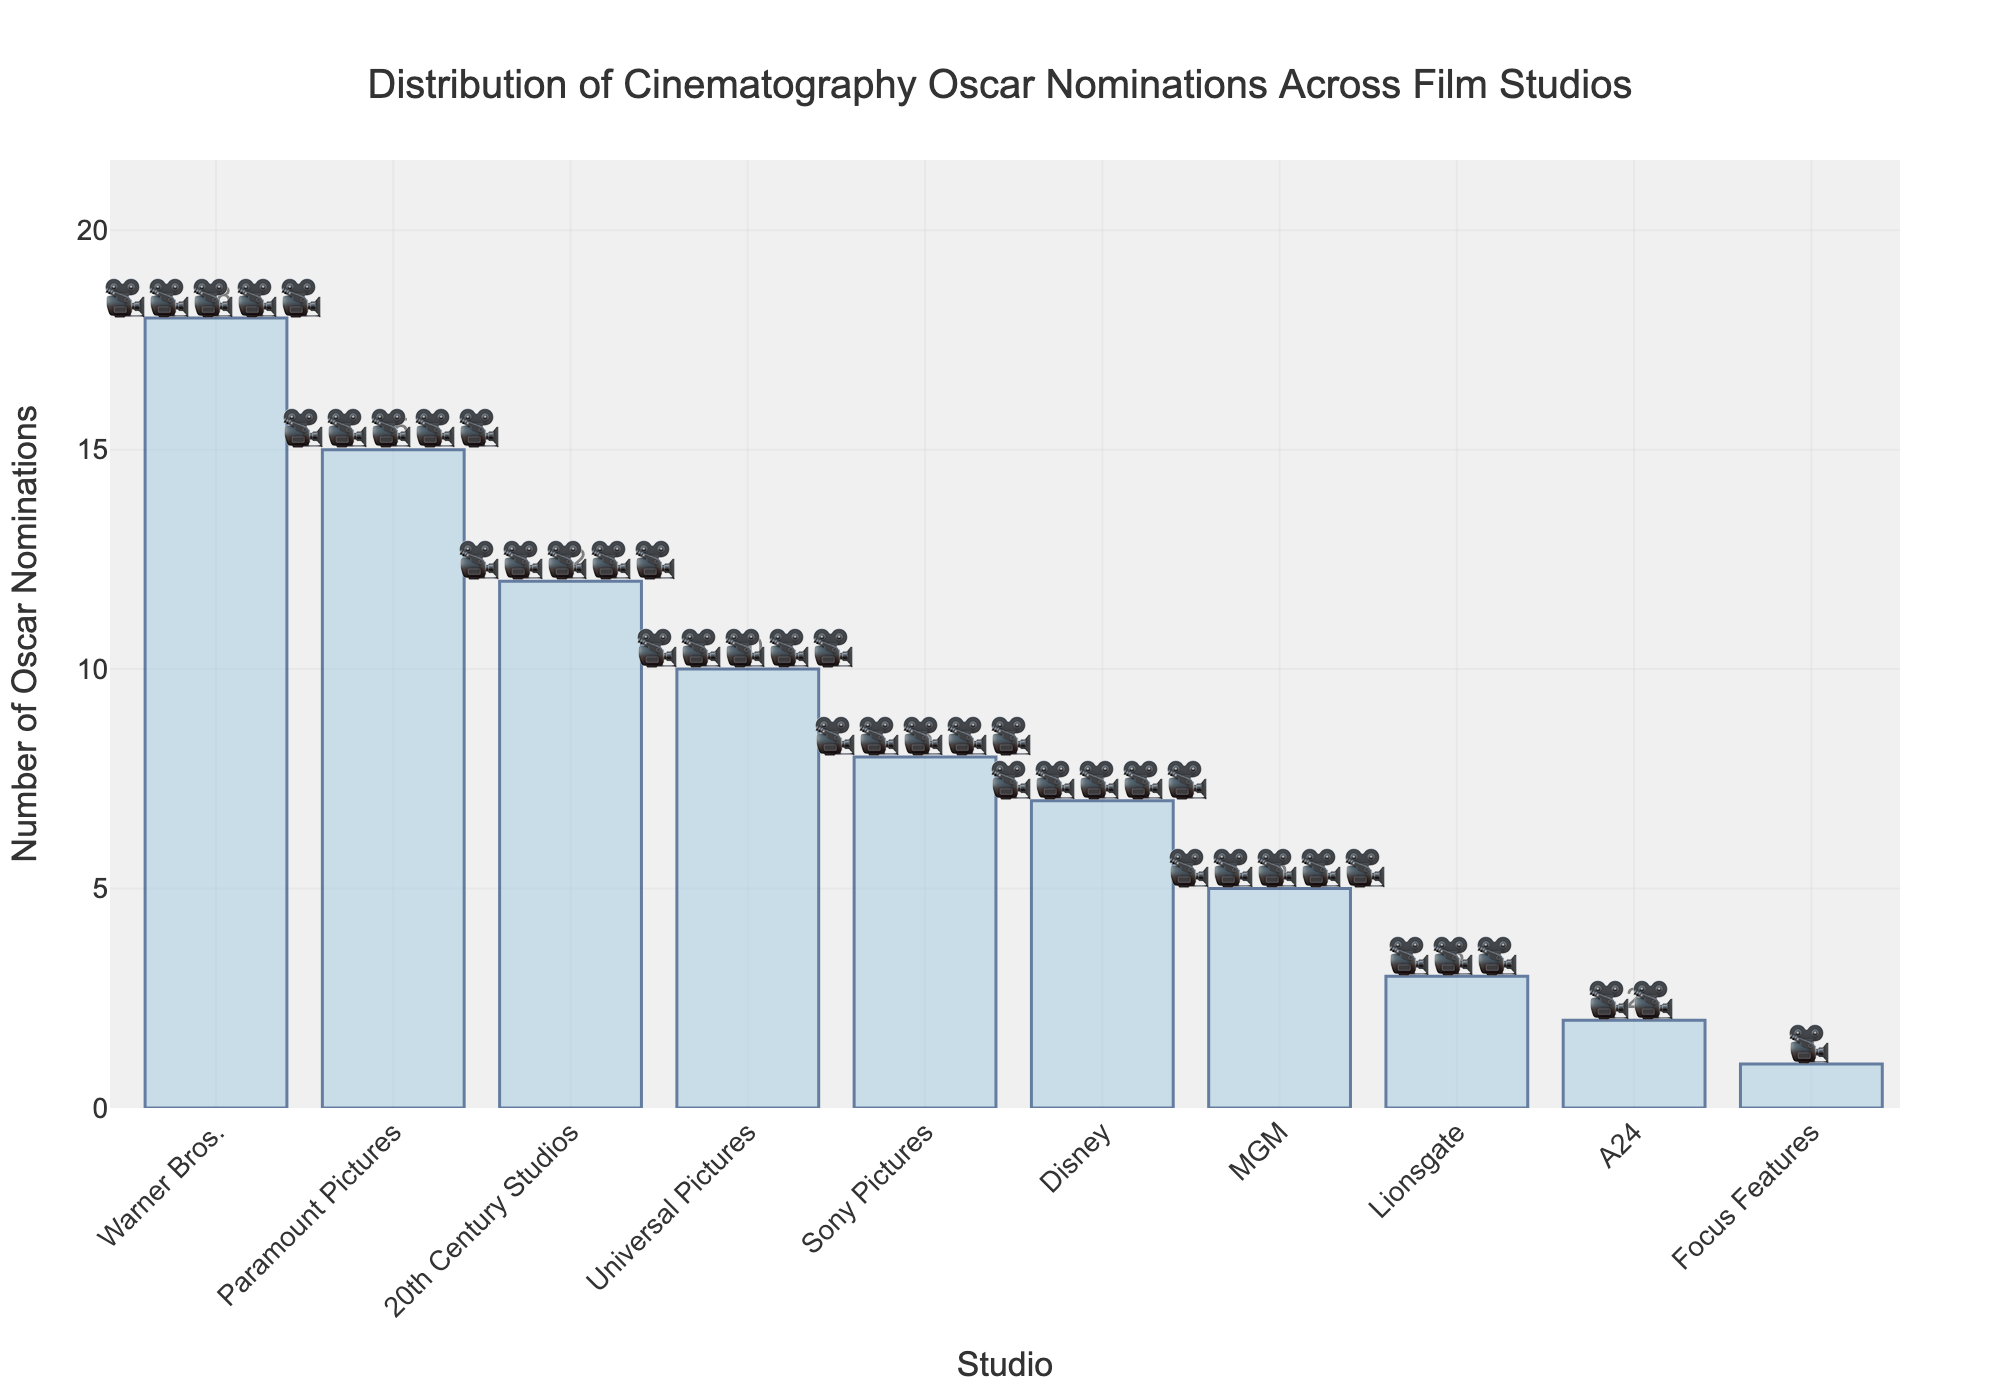What's the title of the figure? Look at the top of the figure where the title is centered. The text there provides the title.
Answer: Distribution of Cinematography Oscar Nominations Across Film Studios Which studio has the most Oscar nominations? Identify the tallest bar in the chart and read the label on the x-axis that corresponds to it.
Answer: Warner Bros How many studios have received more than 10 Oscar nominations? Count the number of bars that have a height corresponding to more than 10 nominations.
Answer: 3 What is the total number of Oscar nominations received by Paramount Pictures and 20th Century Studios combined? Locate the bars for Paramount Pictures and 20th Century Studios, read the number of nominations for each, and sum them up (15 + 12).
Answer: 27 Which studio is ranked third in terms of Oscar nominations? Order the studios by the height of their bars in descending order and find the third one on the list, which has the third highest number of nominations.
Answer: 20th Century Studios By how many nominations does the studio with the most nominations exceed the studio with the second most nominations? Identify the nominations for Warner Bros. (18) and Paramount Pictures (15) and subtract the latter from the former.
Answer: 3 How many studios have fewer than 5 Oscar nominations? Count the bars that have a height corresponding to fewer than 5 nominations.
Answer: 4 What is the average number of Oscar nominations per studio? Sum all the nominations and divide by the number of studios. Calculation: (18 + 15 + 12 + 10 + 8 + 7 + 5 + 3 + 2 + 1) / 10 = 8.1
Answer: 8.1 Which studios received exactly as many nominations as they have 🎥 emojis shown? Look for studios with the number of nominations 5 or less, then match the number of nominations with the number of 🎥 emojis next to their corresponding bars.
Answer: Disney, MGM, Lionsgate, A24, Focus Features What is the difference in Oscar nominations between the studio with the fewest and the studio with the second fewest nominations? Identify the nominations for Focus Features (1) and A24 (2) and subtract the former from the latter.
Answer: 1 